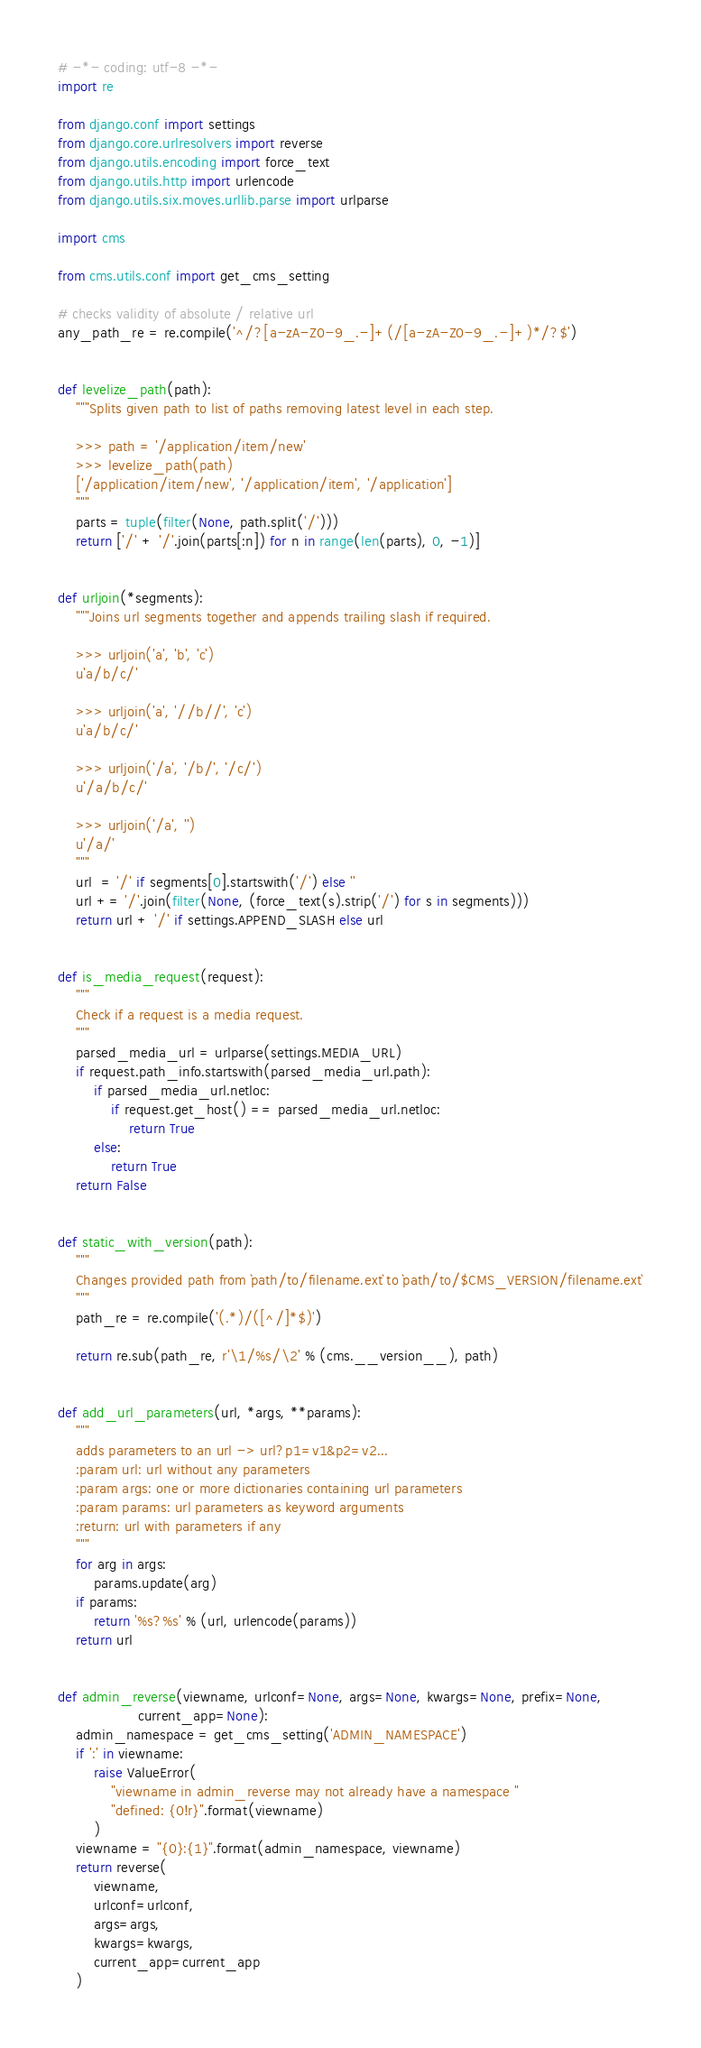Convert code to text. <code><loc_0><loc_0><loc_500><loc_500><_Python_># -*- coding: utf-8 -*-
import re

from django.conf import settings
from django.core.urlresolvers import reverse
from django.utils.encoding import force_text
from django.utils.http import urlencode
from django.utils.six.moves.urllib.parse import urlparse

import cms

from cms.utils.conf import get_cms_setting

# checks validity of absolute / relative url
any_path_re = re.compile('^/?[a-zA-Z0-9_.-]+(/[a-zA-Z0-9_.-]+)*/?$')


def levelize_path(path):
    """Splits given path to list of paths removing latest level in each step.

    >>> path = '/application/item/new'
    >>> levelize_path(path)
    ['/application/item/new', '/application/item', '/application']
    """
    parts = tuple(filter(None, path.split('/')))
    return ['/' + '/'.join(parts[:n]) for n in range(len(parts), 0, -1)]


def urljoin(*segments):
    """Joins url segments together and appends trailing slash if required.

    >>> urljoin('a', 'b', 'c')
    u'a/b/c/'

    >>> urljoin('a', '//b//', 'c')
    u'a/b/c/'

    >>> urljoin('/a', '/b/', '/c/')
    u'/a/b/c/'

    >>> urljoin('/a', '')
    u'/a/'
    """
    url  = '/' if segments[0].startswith('/') else ''
    url += '/'.join(filter(None, (force_text(s).strip('/') for s in segments)))
    return url + '/' if settings.APPEND_SLASH else url


def is_media_request(request):
    """
    Check if a request is a media request.
    """
    parsed_media_url = urlparse(settings.MEDIA_URL)
    if request.path_info.startswith(parsed_media_url.path):
        if parsed_media_url.netloc:
            if request.get_host() == parsed_media_url.netloc:
                return True
        else:
            return True
    return False


def static_with_version(path):
    """
    Changes provided path from `path/to/filename.ext` to `path/to/$CMS_VERSION/filename.ext`
    """
    path_re = re.compile('(.*)/([^/]*$)')

    return re.sub(path_re, r'\1/%s/\2' % (cms.__version__), path)


def add_url_parameters(url, *args, **params):
    """
    adds parameters to an url -> url?p1=v1&p2=v2...
    :param url: url without any parameters
    :param args: one or more dictionaries containing url parameters
    :param params: url parameters as keyword arguments
    :return: url with parameters if any
    """
    for arg in args:
        params.update(arg)
    if params:
        return '%s?%s' % (url, urlencode(params))
    return url


def admin_reverse(viewname, urlconf=None, args=None, kwargs=None, prefix=None,
                  current_app=None):
    admin_namespace = get_cms_setting('ADMIN_NAMESPACE')
    if ':' in viewname:
        raise ValueError(
            "viewname in admin_reverse may not already have a namespace "
            "defined: {0!r}".format(viewname)
        )
    viewname = "{0}:{1}".format(admin_namespace, viewname)
    return reverse(
        viewname,
        urlconf=urlconf,
        args=args,
        kwargs=kwargs,
        current_app=current_app
    )
</code> 